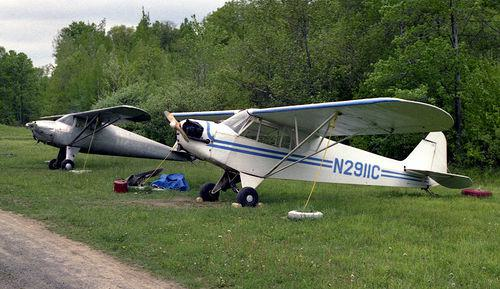How many aeroplanes would there be in the image if one additional aeroplane was added in the scence? 3 